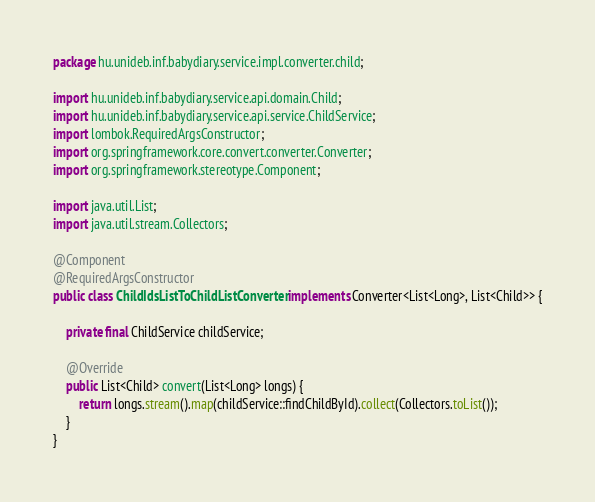Convert code to text. <code><loc_0><loc_0><loc_500><loc_500><_Java_>package hu.unideb.inf.babydiary.service.impl.converter.child;

import hu.unideb.inf.babydiary.service.api.domain.Child;
import hu.unideb.inf.babydiary.service.api.service.ChildService;
import lombok.RequiredArgsConstructor;
import org.springframework.core.convert.converter.Converter;
import org.springframework.stereotype.Component;

import java.util.List;
import java.util.stream.Collectors;

@Component
@RequiredArgsConstructor
public class ChildIdsListToChildListConverter implements Converter<List<Long>, List<Child>> {

    private final ChildService childService;

    @Override
    public List<Child> convert(List<Long> longs) {
        return longs.stream().map(childService::findChildById).collect(Collectors.toList());
    }
}
</code> 